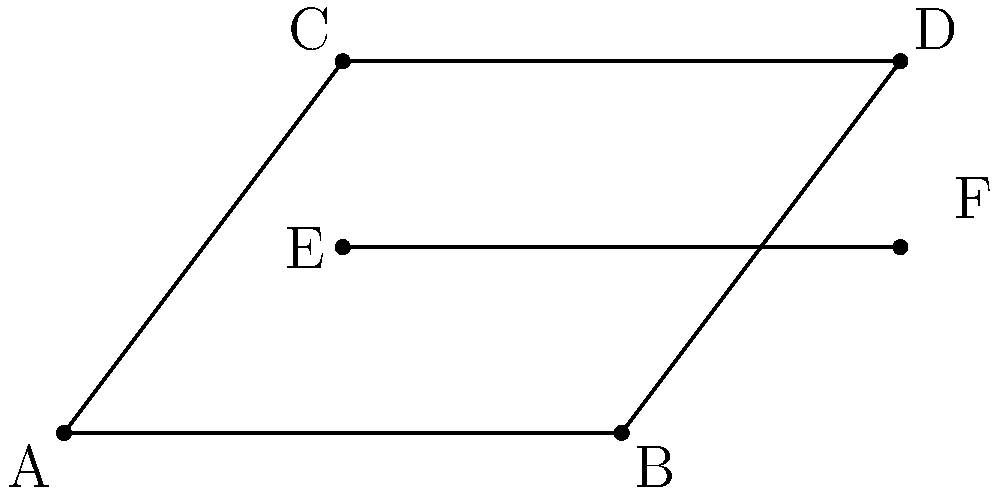In the roof truss diagram of a 15th-century parish church in East Sussex, triangles ABC and BCD are shown. Which of the following statements about these triangles is true and can be used to prove they are congruent? To determine if triangles ABC and BCD are congruent, we need to examine their sides and angles:

1. Side AB is shared by both triangles, so AB = BC.
2. AC and BD are both diagonals of the rectangle ABCD, so AC = BD.
3. Line EF is parallel to AB and bisects AC and BD, creating congruent segments:
   AE = EC and BF = FD.
4. Since AE = EC and BF = FD, we can conclude that BC = CD.

Now, we can apply the Side-Side-Side (SSS) congruence theorem:
- AB = BC (shared side)
- AC = BD (diagonals of a rectangle)
- BC = CD (proved in step 4)

Therefore, triangles ABC and BCD are congruent by the SSS congruence theorem.
Answer: SSS congruence theorem 